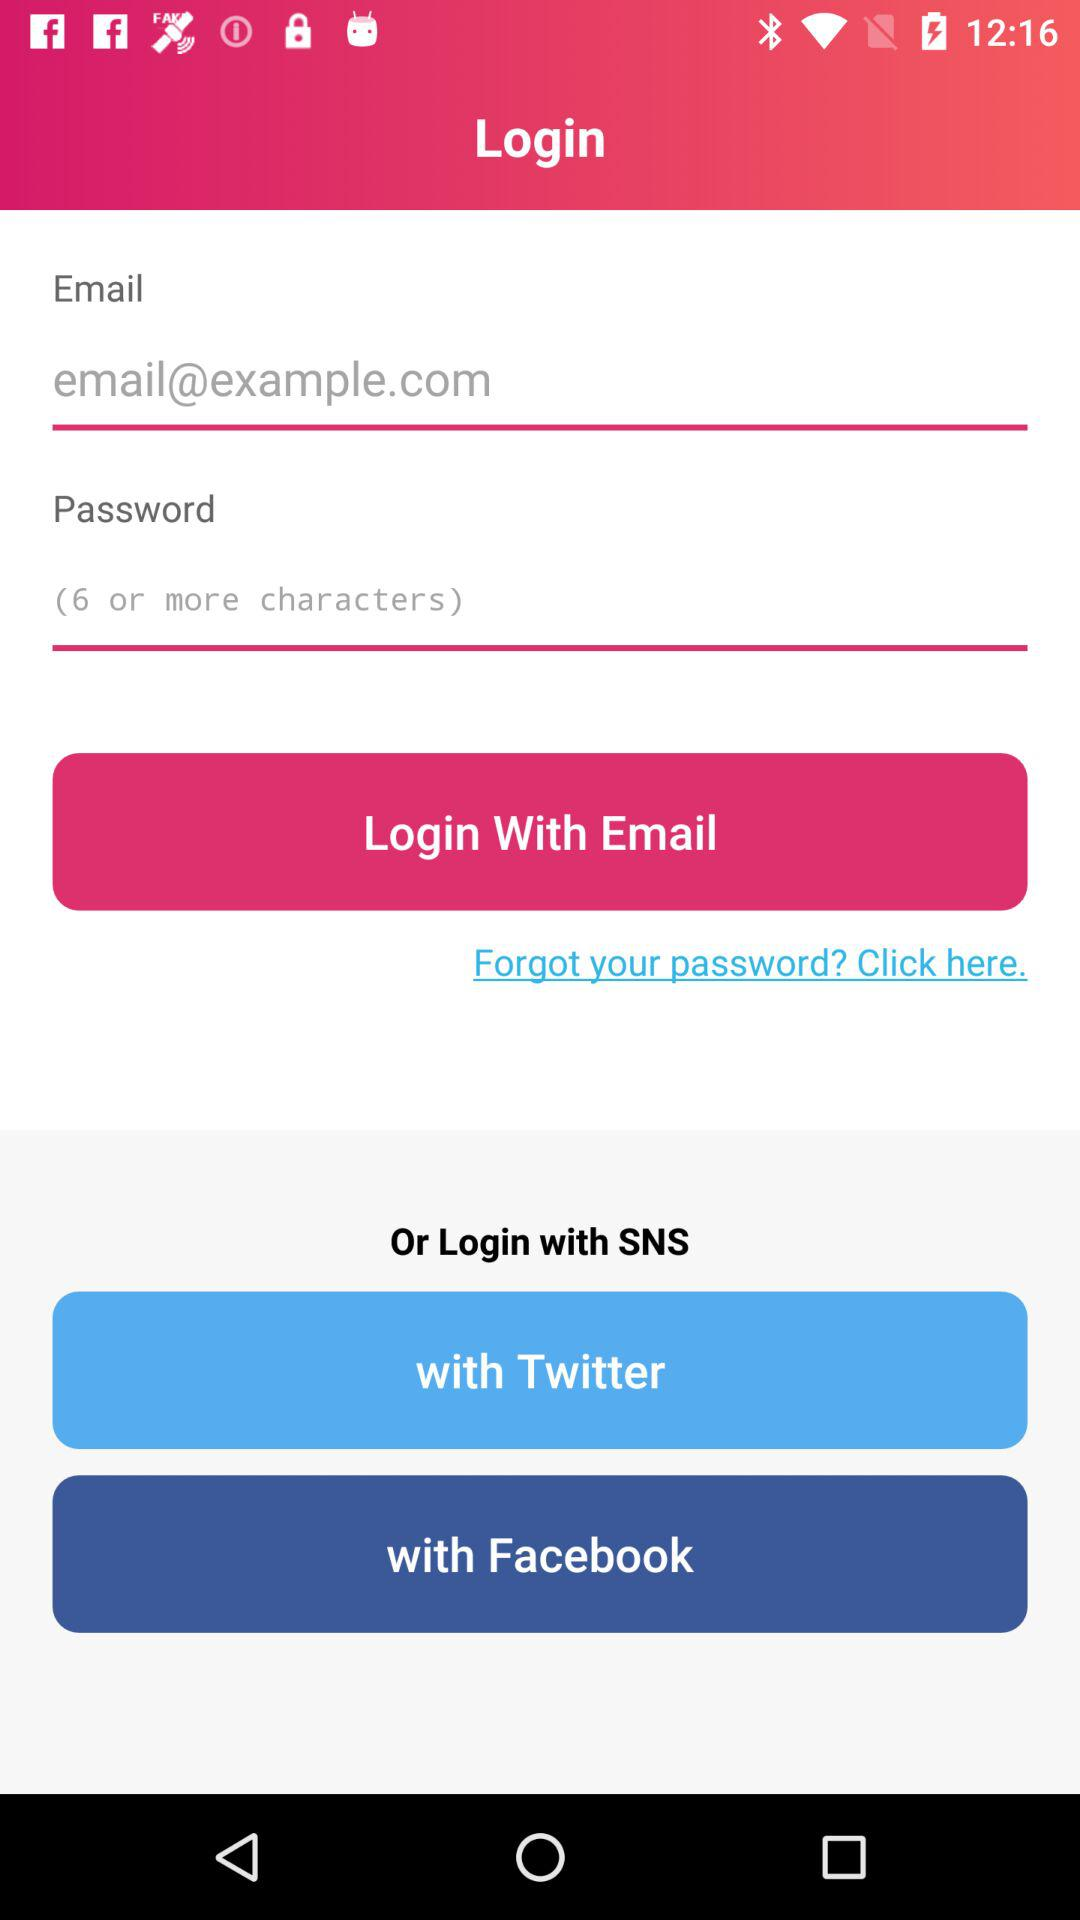How many fields do you need to fill in to login?
Answer the question using a single word or phrase. 2 